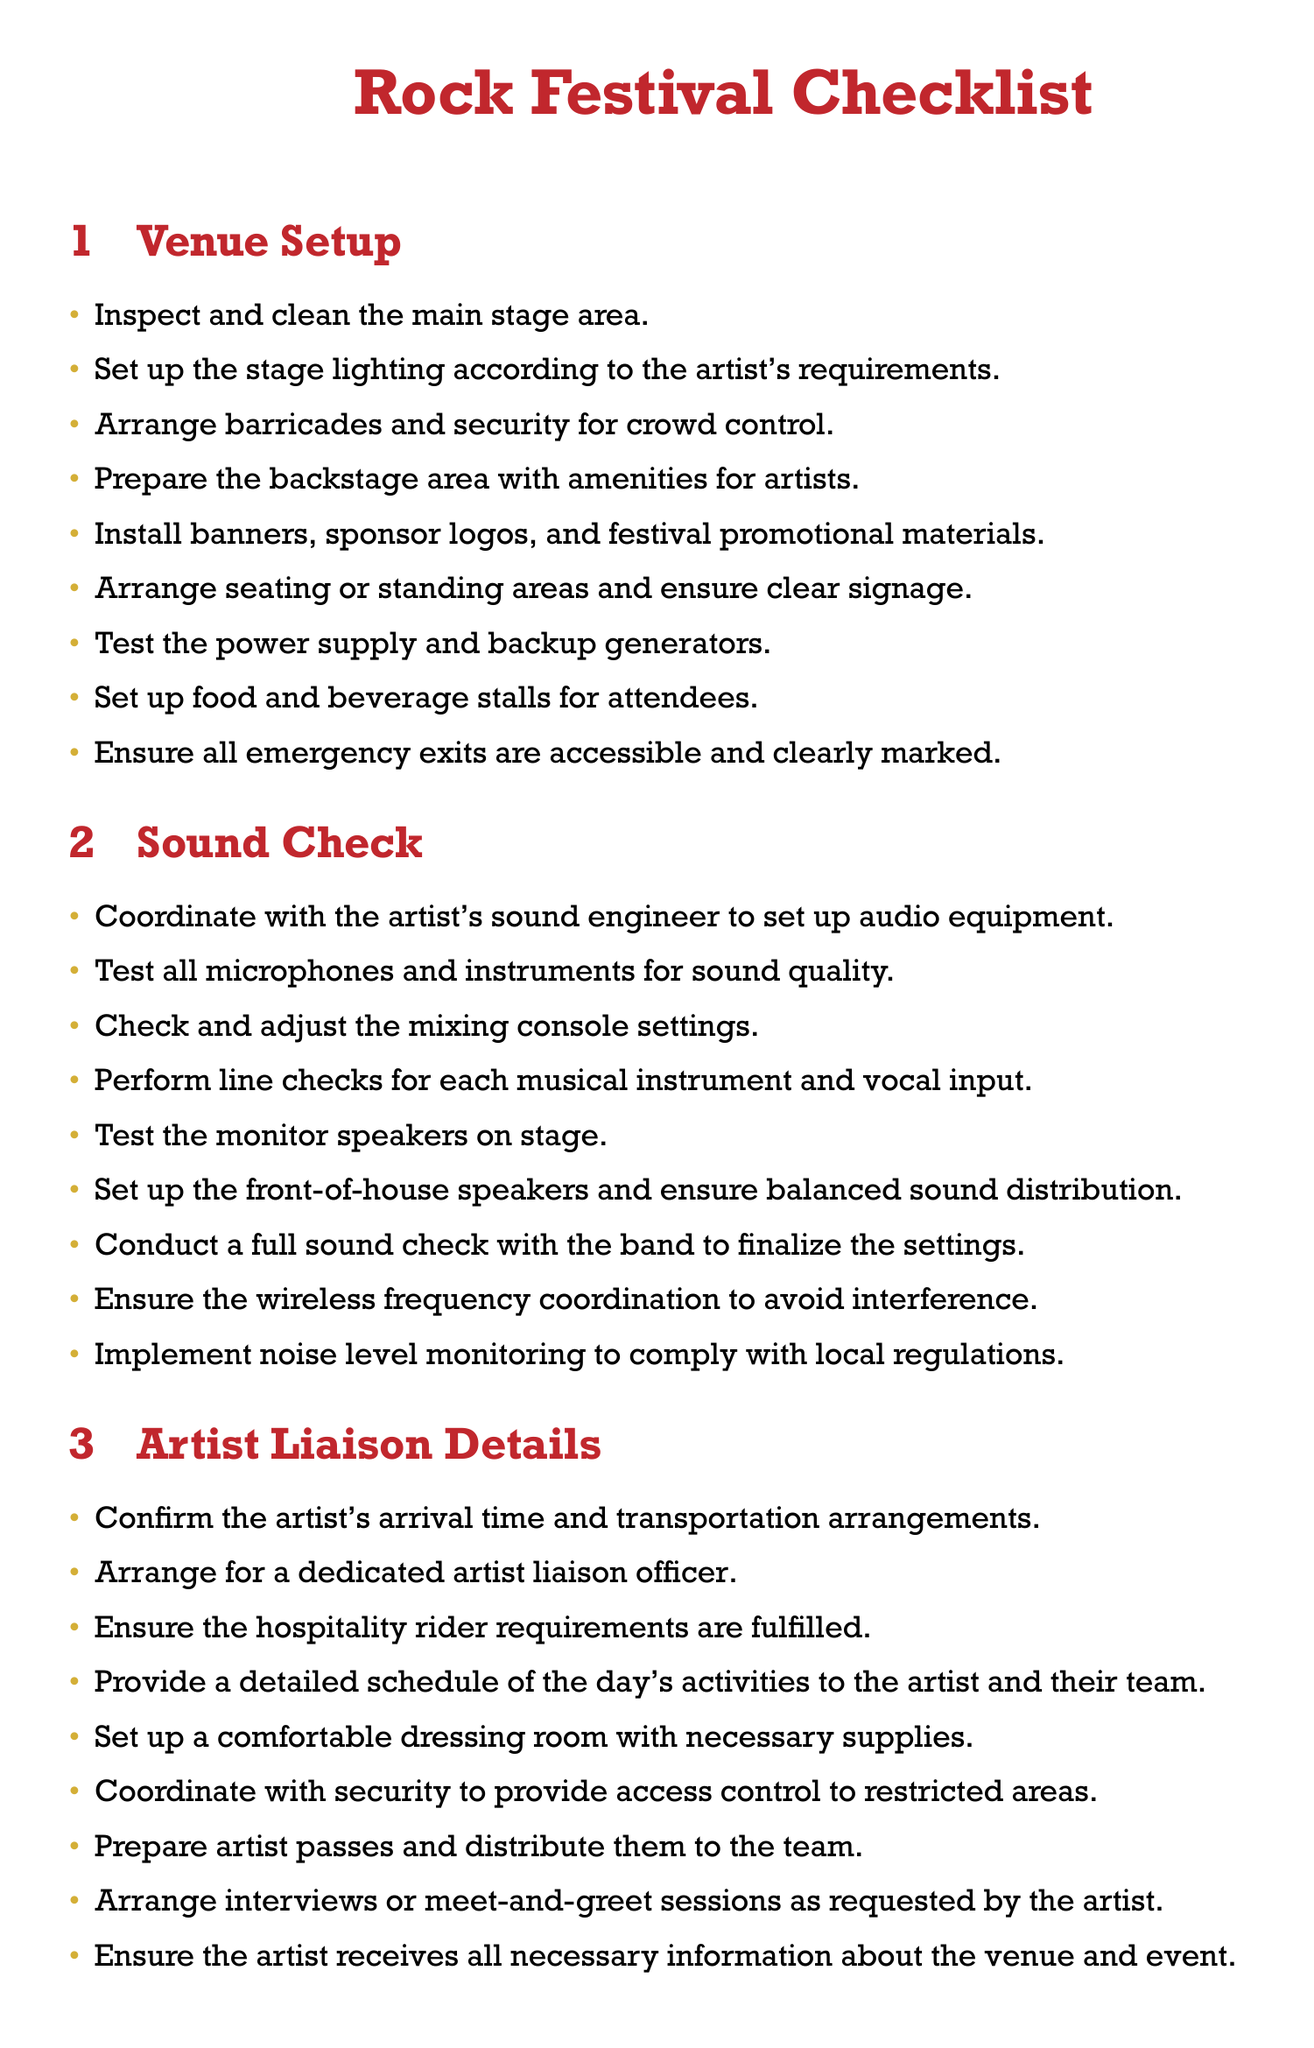What is the color used for the main title? The main title color specified in the document is rockred.
Answer: rockred How many items are listed under Venue Setup? The number of items listed can be counted in the Venue Setup section, which has nine items.
Answer: 9 What is required to be tested regarding the sound equipment? The sound check section includes testing all microphones and instruments for sound quality.
Answer: sound quality What needs to be arranged for the artist upon arrival? The Artist Liaison Details specify confirming the artist’s arrival time and transportation arrangements.
Answer: transportation arrangements What type of officer is needed for artist liaison? The document states that a dedicated artist liaison officer should be arranged.
Answer: dedicated officer How many emergency exits must be checked? The checklist mentions ensuring all emergency exits are accessible and clearly marked.
Answer: all exits What must be fulfilled according to the hospitality rider? The checklist requires ensuring hospitality rider requirements are fulfilled.
Answer: hospitality requirements What color is used for bullets in the checklist? The bullets in the checklist are marked with the color rockgold.
Answer: rockgold How many sound check tasks are there? The sound check section includes nine tasks to be performed.
Answer: 9 